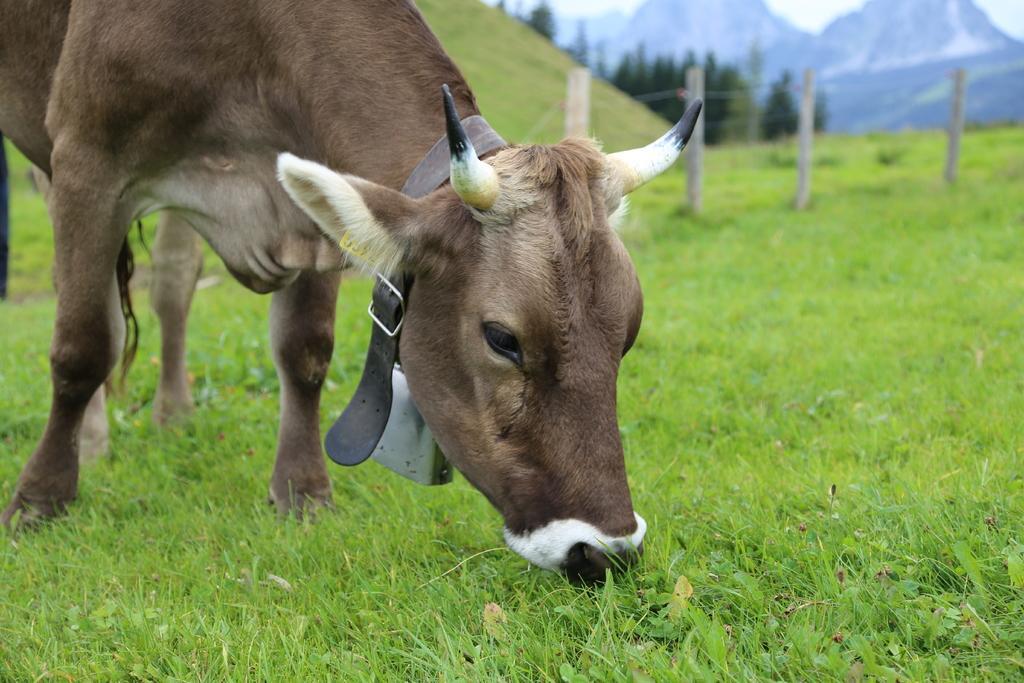Please provide a concise description of this image. In this image we can see a cow grazing the grass. In the background there are fence, trees, hills, mountains and sky. 